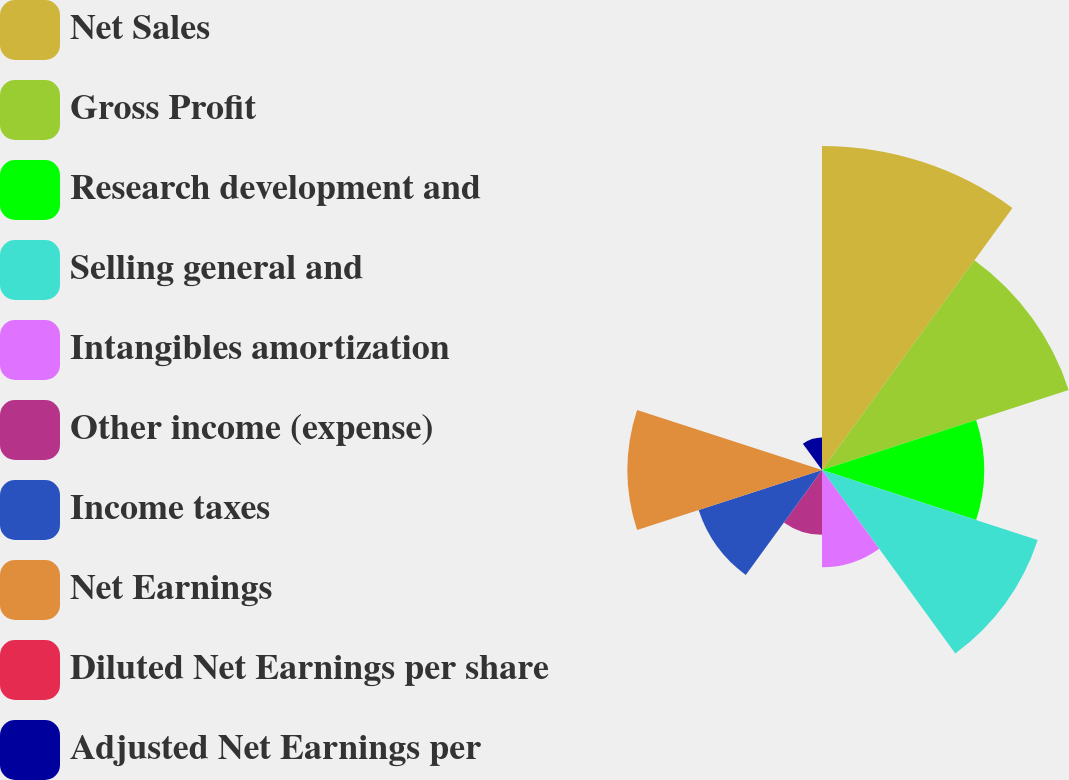Convert chart. <chart><loc_0><loc_0><loc_500><loc_500><pie_chart><fcel>Net Sales<fcel>Gross Profit<fcel>Research development and<fcel>Selling general and<fcel>Intangibles amortization<fcel>Other income (expense)<fcel>Income taxes<fcel>Net Earnings<fcel>Diluted Net Earnings per share<fcel>Adjusted Net Earnings per<nl><fcel>21.73%<fcel>17.39%<fcel>10.87%<fcel>15.21%<fcel>6.52%<fcel>4.35%<fcel>8.7%<fcel>13.04%<fcel>0.01%<fcel>2.18%<nl></chart> 